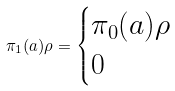<formula> <loc_0><loc_0><loc_500><loc_500>\pi _ { 1 } ( a ) \rho = \begin{cases} \pi _ { 0 } ( a ) \rho & \\ 0 & \end{cases}</formula> 